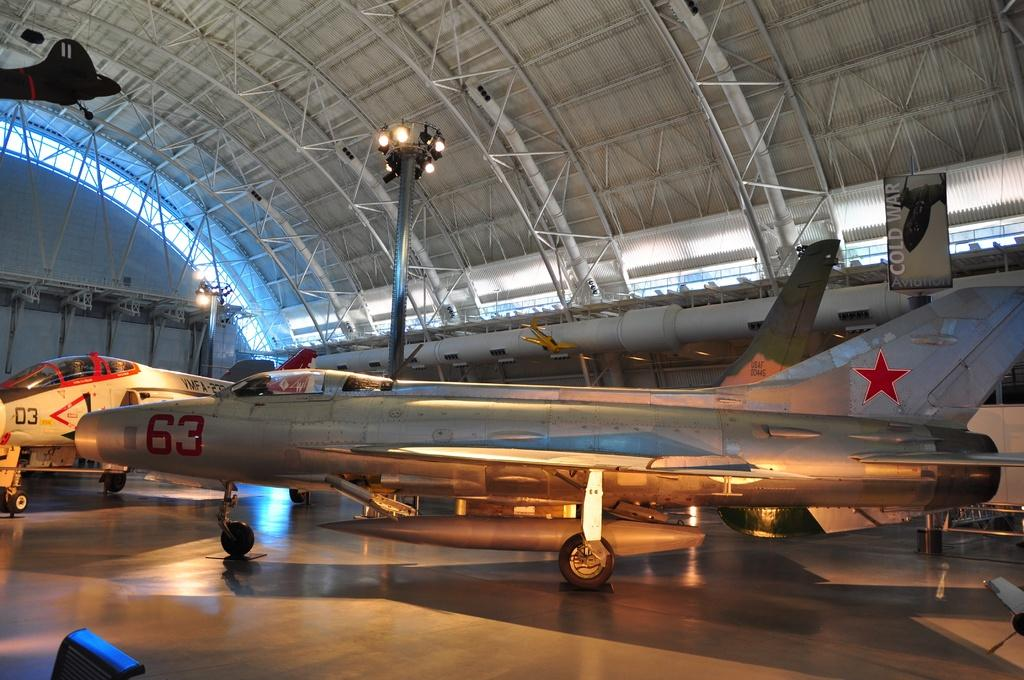<image>
Summarize the visual content of the image. Planes in an air museum include one with a 63 on it 